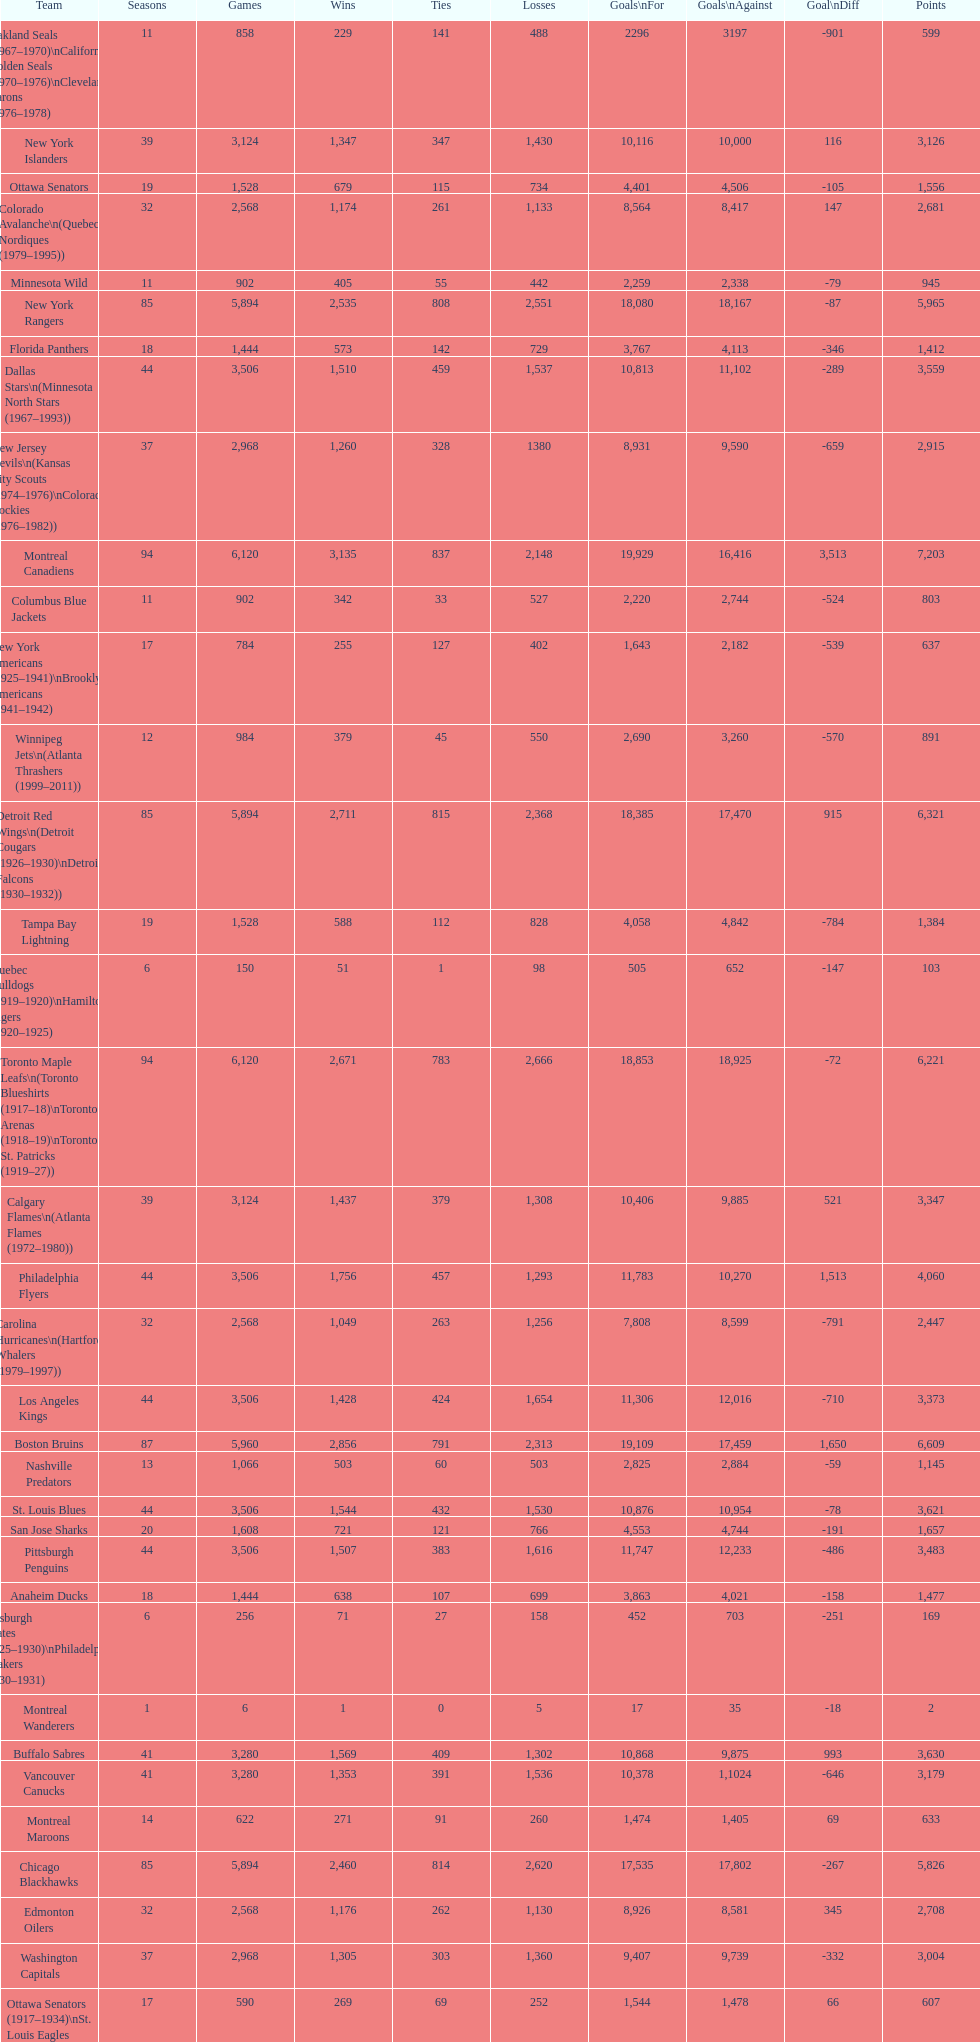What is the number of games that the vancouver canucks have won up to this point? 1,353. 